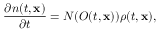<formula> <loc_0><loc_0><loc_500><loc_500>\frac { \partial n ( t , x ) } { \partial t } = N ( O ( t , x ) ) \rho ( t , x ) ,</formula> 